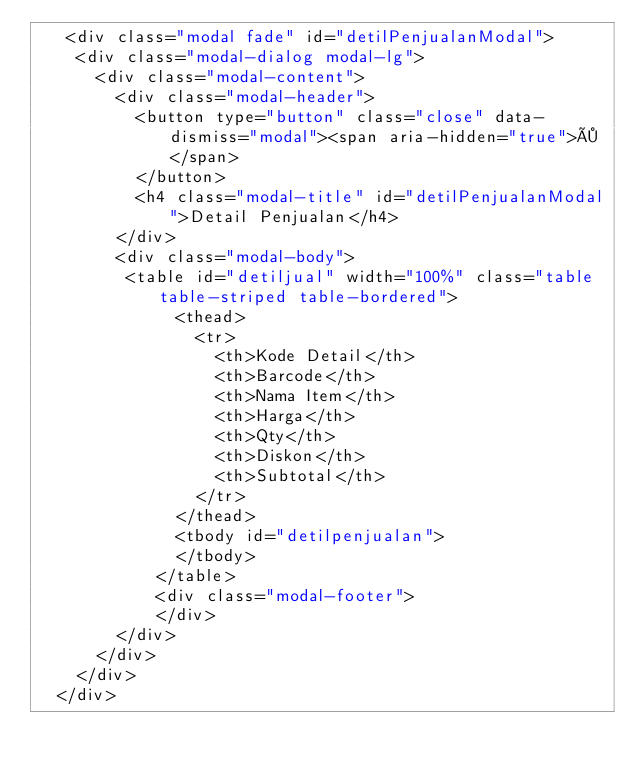<code> <loc_0><loc_0><loc_500><loc_500><_PHP_>   <div class="modal fade" id="detilPenjualanModal">
	<div class="modal-dialog modal-lg">
	  <div class="modal-content">
		<div class="modal-header">
		  <button type="button" class="close" data-dismiss="modal"><span aria-hidden="true">×</span>
		  </button>
		  <h4 class="modal-title" id="detilPenjualanModal">Detail Penjualan</h4>
		</div>
		<div class="modal-body">
		 <table id="detiljual" width="100%" class="table table-striped table-bordered">
			  <thead>
				<tr>
				  <th>Kode Detail</th>
				  <th>Barcode</th>
				  <th>Nama Item</th> 
				  <th>Harga</th>
				  <th>Qty</th>
				  <th>Diskon</th>
				  <th>Subtotal</th>
				</tr>
			  </thead>
			  <tbody id="detilpenjualan">
			  </tbody>
			</table>
			<div class="modal-footer">
			</div>
		</div>
	  </div>
	</div>
  </div></code> 